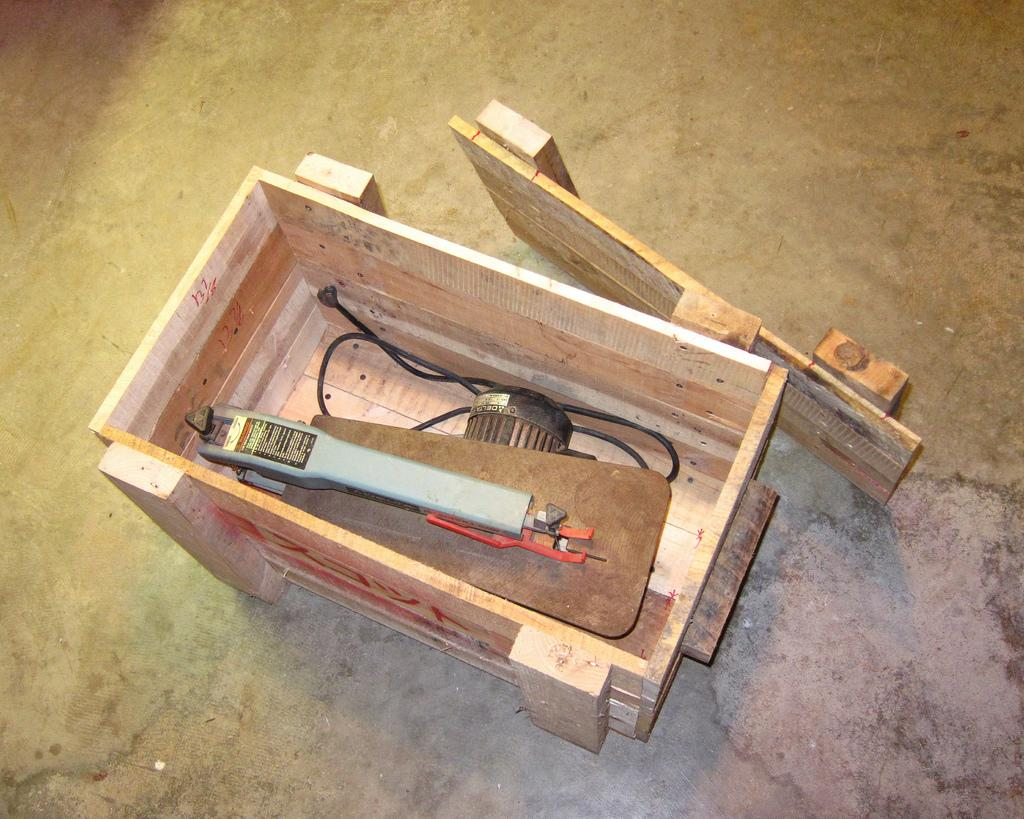What object is in the image that is made of wood? There is a wooden box in the image. What is inside the wooden box? The wooden box contains a cutting machine. Where is the wooden box located in the image? The wooden box is on the floor. How much snow is on top of the wooden box in the image? There is no snow present in the image; it is a wooden box containing a cutting machine and located on the floor. 